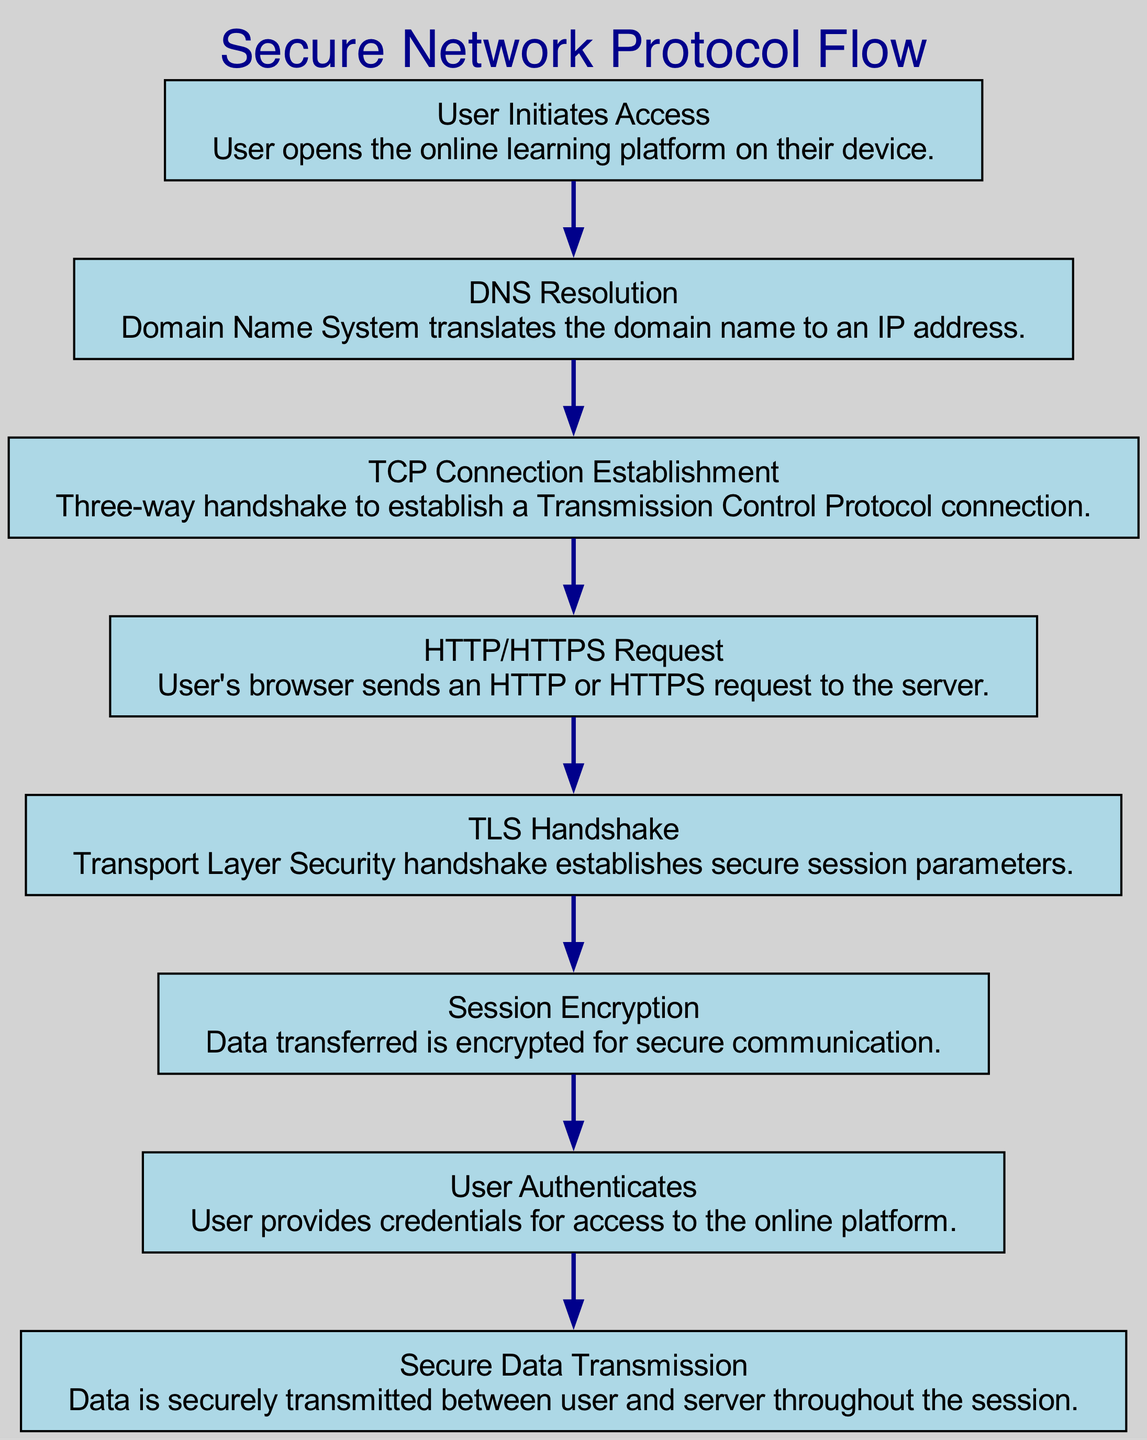What is the first step in the flow chart? The first step is "User Initiates Access," indicating that the user opens the online learning platform.
Answer: User Initiates Access How many nodes are in the flow chart? By counting the total elements listed, there are eight nodes present in the flow chart.
Answer: Eight What does the "TLS Handshake" establish? The "TLS Handshake" establishes secure session parameters between the user and the server.
Answer: Secure session parameters Which two nodes are directly connected before the "Session Encryption"? The two nodes connected before "Session Encryption" are "TLS Handshake" and "User Authenticates."
Answer: TLS Handshake and User Authenticates What is the purpose of "Session Encryption" in the flow? The purpose of "Session Encryption" is to ensure that data transferred is encrypted for secure communication throughout the session.
Answer: Data is encrypted for secure communication Which process occurs directly after "DNS Resolution"? The process that occurs directly after "DNS Resolution" is "TCP Connection Establishment," indicating the start of connection setup.
Answer: TCP Connection Establishment What type of request is sent by the user's browser? The user's browser sends an "HTTP or HTTPS request" to the server to retrieve content.
Answer: HTTP or HTTPS request How does the user gain access to the online platform? The user gains access to the online platform by authenticating, which involves providing their credentials.
Answer: User authenticates 